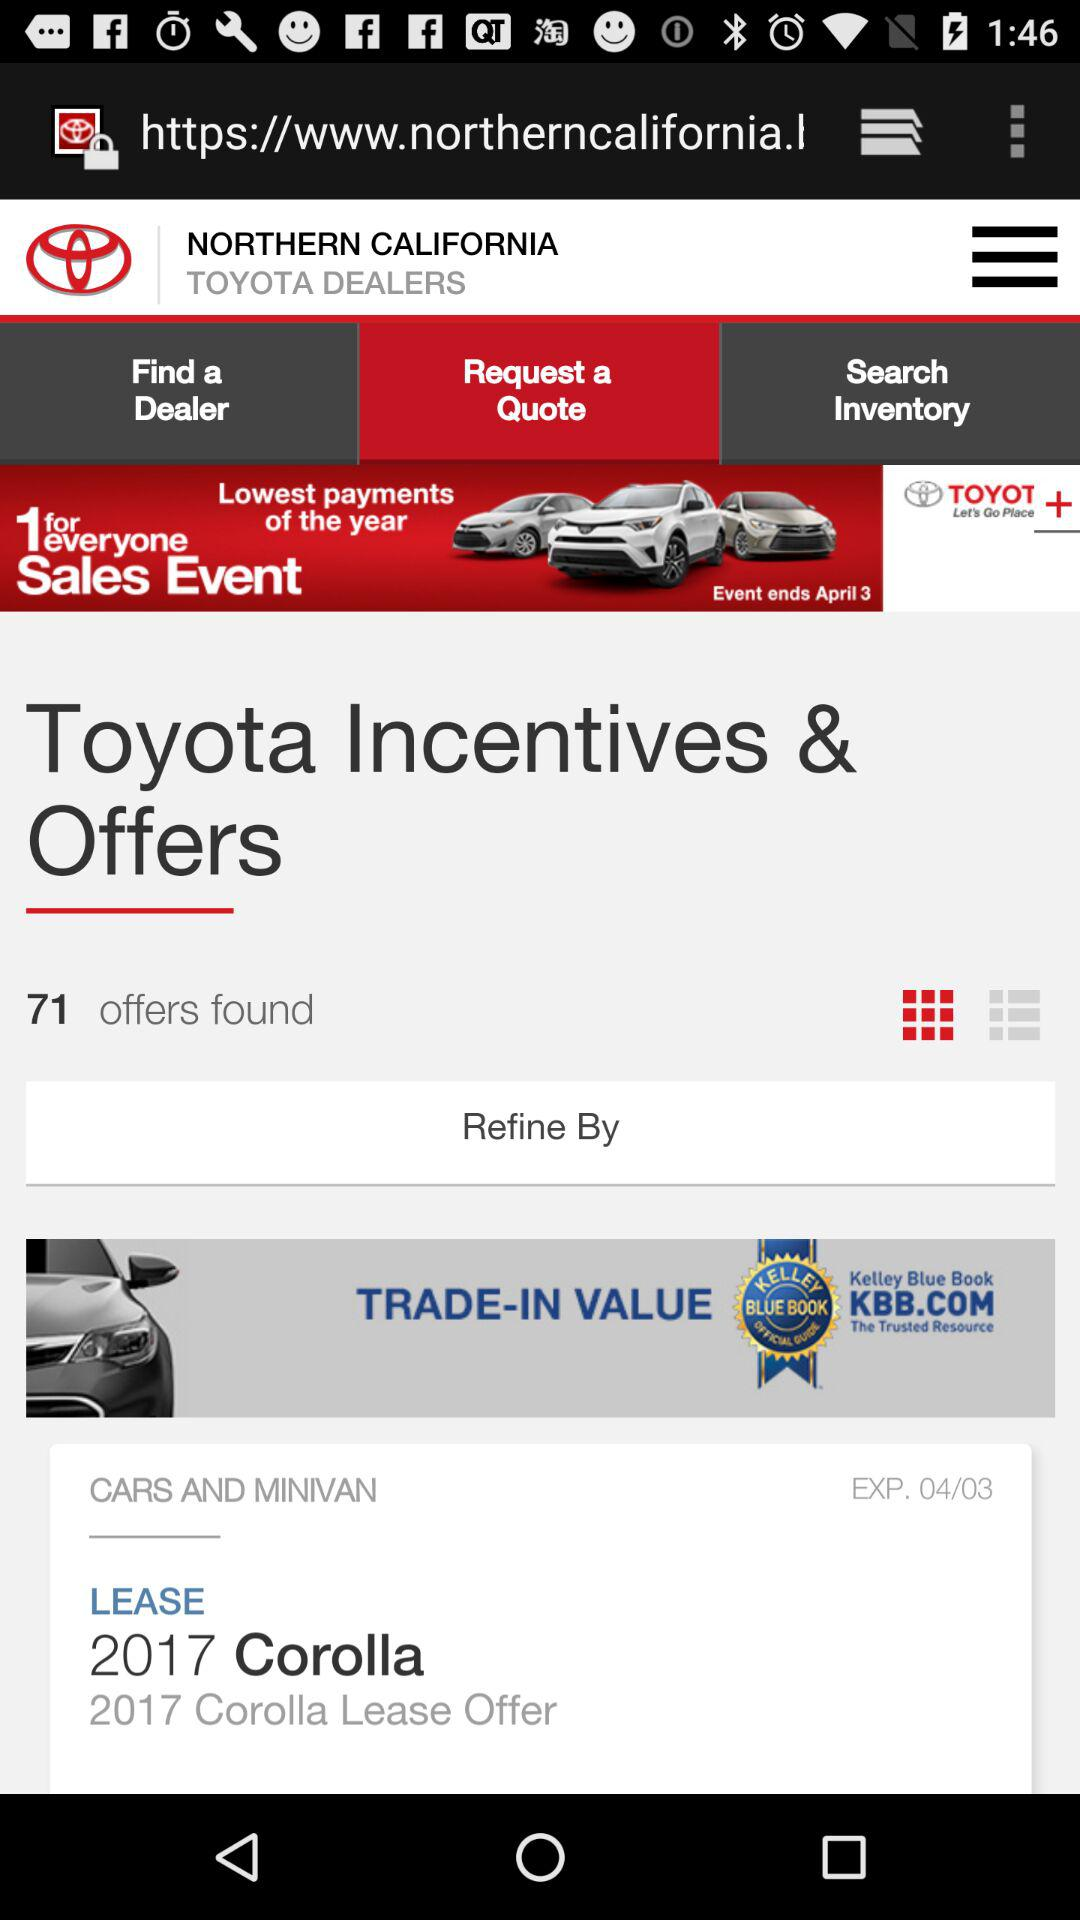How many offers have been found? The number of offers that have been found is 71. 